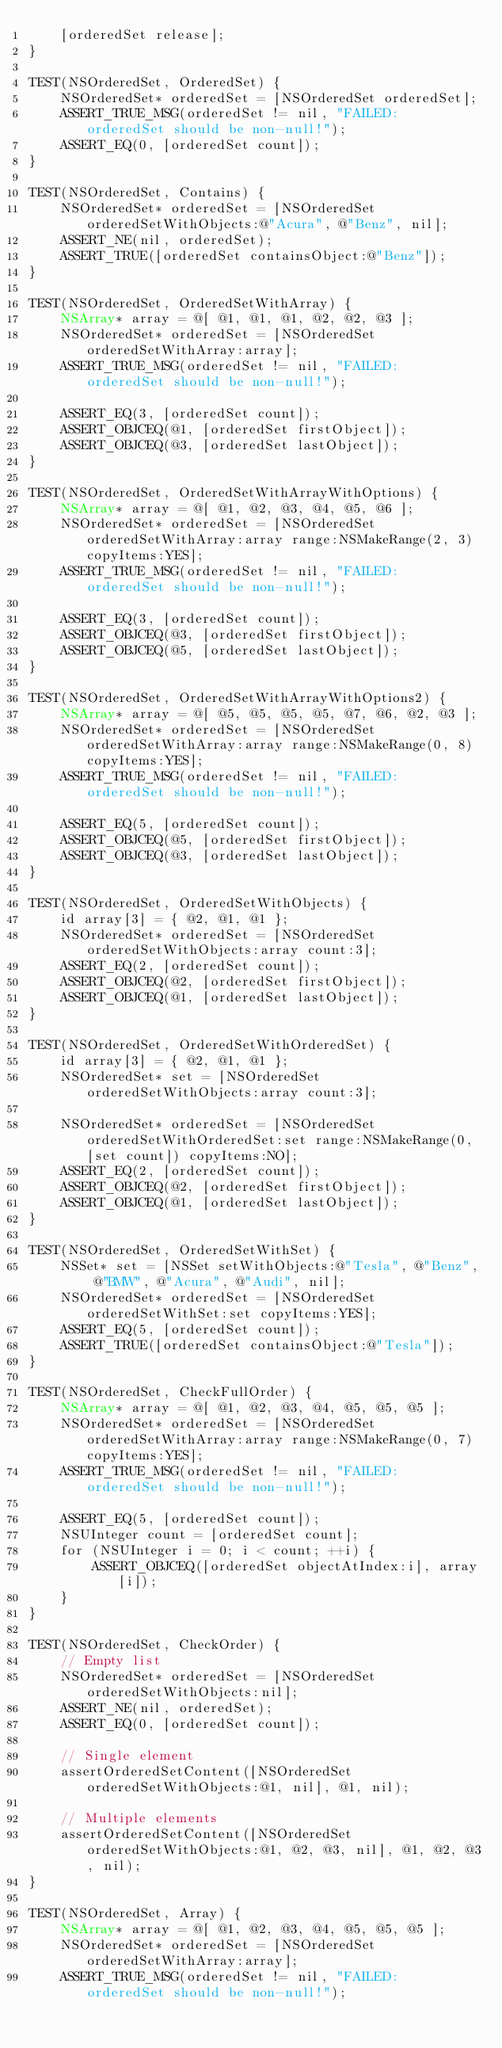Convert code to text. <code><loc_0><loc_0><loc_500><loc_500><_ObjectiveC_>    [orderedSet release];
}

TEST(NSOrderedSet, OrderedSet) {
    NSOrderedSet* orderedSet = [NSOrderedSet orderedSet];
    ASSERT_TRUE_MSG(orderedSet != nil, "FAILED: orderedSet should be non-null!");
    ASSERT_EQ(0, [orderedSet count]);
}

TEST(NSOrderedSet, Contains) {
    NSOrderedSet* orderedSet = [NSOrderedSet orderedSetWithObjects:@"Acura", @"Benz", nil];
    ASSERT_NE(nil, orderedSet);
    ASSERT_TRUE([orderedSet containsObject:@"Benz"]);
}

TEST(NSOrderedSet, OrderedSetWithArray) {
    NSArray* array = @[ @1, @1, @1, @2, @2, @3 ];
    NSOrderedSet* orderedSet = [NSOrderedSet orderedSetWithArray:array];
    ASSERT_TRUE_MSG(orderedSet != nil, "FAILED: orderedSet should be non-null!");

    ASSERT_EQ(3, [orderedSet count]);
    ASSERT_OBJCEQ(@1, [orderedSet firstObject]);
    ASSERT_OBJCEQ(@3, [orderedSet lastObject]);
}

TEST(NSOrderedSet, OrderedSetWithArrayWithOptions) {
    NSArray* array = @[ @1, @2, @3, @4, @5, @6 ];
    NSOrderedSet* orderedSet = [NSOrderedSet orderedSetWithArray:array range:NSMakeRange(2, 3) copyItems:YES];
    ASSERT_TRUE_MSG(orderedSet != nil, "FAILED: orderedSet should be non-null!");

    ASSERT_EQ(3, [orderedSet count]);
    ASSERT_OBJCEQ(@3, [orderedSet firstObject]);
    ASSERT_OBJCEQ(@5, [orderedSet lastObject]);
}

TEST(NSOrderedSet, OrderedSetWithArrayWithOptions2) {
    NSArray* array = @[ @5, @5, @5, @5, @7, @6, @2, @3 ];
    NSOrderedSet* orderedSet = [NSOrderedSet orderedSetWithArray:array range:NSMakeRange(0, 8) copyItems:YES];
    ASSERT_TRUE_MSG(orderedSet != nil, "FAILED: orderedSet should be non-null!");

    ASSERT_EQ(5, [orderedSet count]);
    ASSERT_OBJCEQ(@5, [orderedSet firstObject]);
    ASSERT_OBJCEQ(@3, [orderedSet lastObject]);
}

TEST(NSOrderedSet, OrderedSetWithObjects) {
    id array[3] = { @2, @1, @1 };
    NSOrderedSet* orderedSet = [NSOrderedSet orderedSetWithObjects:array count:3];
    ASSERT_EQ(2, [orderedSet count]);
    ASSERT_OBJCEQ(@2, [orderedSet firstObject]);
    ASSERT_OBJCEQ(@1, [orderedSet lastObject]);
}

TEST(NSOrderedSet, OrderedSetWithOrderedSet) {
    id array[3] = { @2, @1, @1 };
    NSOrderedSet* set = [NSOrderedSet orderedSetWithObjects:array count:3];

    NSOrderedSet* orderedSet = [NSOrderedSet orderedSetWithOrderedSet:set range:NSMakeRange(0, [set count]) copyItems:NO];
    ASSERT_EQ(2, [orderedSet count]);
    ASSERT_OBJCEQ(@2, [orderedSet firstObject]);
    ASSERT_OBJCEQ(@1, [orderedSet lastObject]);
}

TEST(NSOrderedSet, OrderedSetWithSet) {
    NSSet* set = [NSSet setWithObjects:@"Tesla", @"Benz", @"BMW", @"Acura", @"Audi", nil];
    NSOrderedSet* orderedSet = [NSOrderedSet orderedSetWithSet:set copyItems:YES];
    ASSERT_EQ(5, [orderedSet count]);
    ASSERT_TRUE([orderedSet containsObject:@"Tesla"]);
}

TEST(NSOrderedSet, CheckFullOrder) {
    NSArray* array = @[ @1, @2, @3, @4, @5, @5, @5 ];
    NSOrderedSet* orderedSet = [NSOrderedSet orderedSetWithArray:array range:NSMakeRange(0, 7) copyItems:YES];
    ASSERT_TRUE_MSG(orderedSet != nil, "FAILED: orderedSet should be non-null!");

    ASSERT_EQ(5, [orderedSet count]);
    NSUInteger count = [orderedSet count];
    for (NSUInteger i = 0; i < count; ++i) {
        ASSERT_OBJCEQ([orderedSet objectAtIndex:i], array[i]);
    }
}

TEST(NSOrderedSet, CheckOrder) {
    // Empty list
    NSOrderedSet* orderedSet = [NSOrderedSet orderedSetWithObjects:nil];
    ASSERT_NE(nil, orderedSet);
    ASSERT_EQ(0, [orderedSet count]);

    // Single element
    assertOrderedSetContent([NSOrderedSet orderedSetWithObjects:@1, nil], @1, nil);

    // Multiple elements
    assertOrderedSetContent([NSOrderedSet orderedSetWithObjects:@1, @2, @3, nil], @1, @2, @3, nil);
}

TEST(NSOrderedSet, Array) {
    NSArray* array = @[ @1, @2, @3, @4, @5, @5, @5 ];
    NSOrderedSet* orderedSet = [NSOrderedSet orderedSetWithArray:array];
    ASSERT_TRUE_MSG(orderedSet != nil, "FAILED: orderedSet should be non-null!");
</code> 